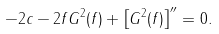<formula> <loc_0><loc_0><loc_500><loc_500>- 2 c - 2 f G ^ { 2 } ( f ) + \left [ G ^ { 2 } ( f ) \right ] ^ { \prime \prime } = 0 .</formula> 